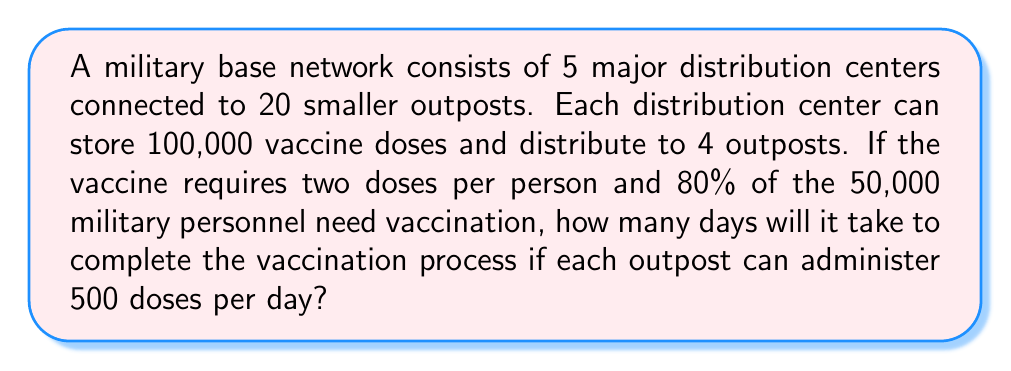Teach me how to tackle this problem. Let's approach this step-by-step:

1) First, calculate the total number of doses needed:
   $$ \text{Total doses} = 50,000 \times 0.80 \times 2 = 80,000 $$

2) Each distribution center can store 100,000 doses, so storage is not a limiting factor.

3) Number of outposts that can administer vaccines:
   $$ \text{Outposts} = 5 \times 4 = 20 $$

4) Total daily vaccination capacity:
   $$ \text{Daily capacity} = 20 \times 500 = 10,000 \text{ doses/day} $$

5) Time to administer all doses:
   $$ \text{Days} = \frac{\text{Total doses}}{\text{Daily capacity}} = \frac{80,000}{10,000} = 8 \text{ days} $$

Therefore, it will take 8 days to complete the vaccination process.
Answer: 8 days 